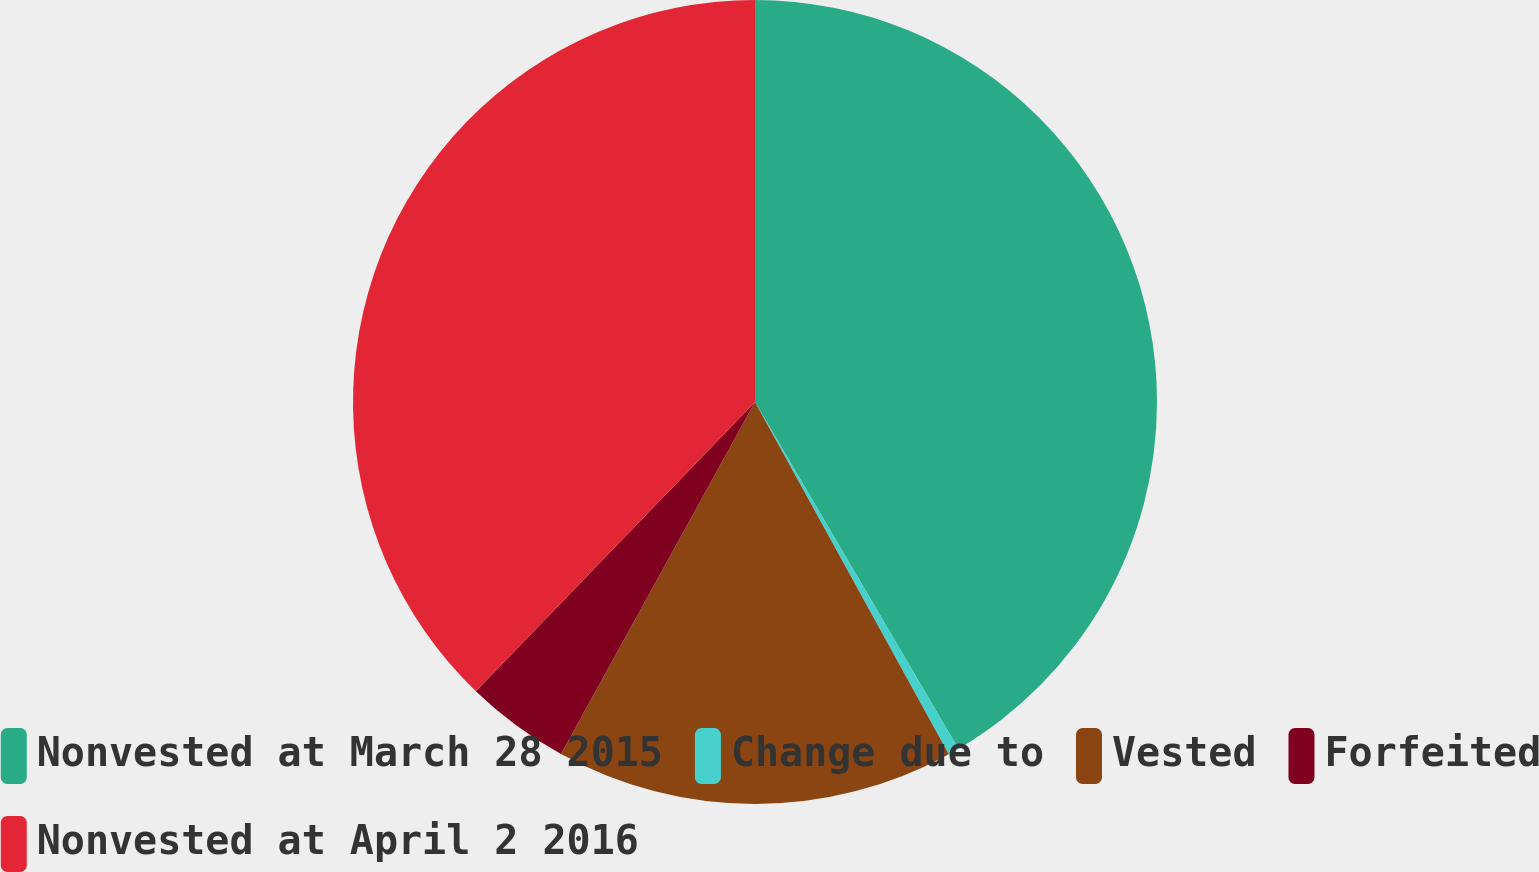Convert chart. <chart><loc_0><loc_0><loc_500><loc_500><pie_chart><fcel>Nonvested at March 28 2015<fcel>Change due to<fcel>Vested<fcel>Forfeited<fcel>Nonvested at April 2 2016<nl><fcel>41.55%<fcel>0.44%<fcel>16.02%<fcel>4.2%<fcel>37.78%<nl></chart> 